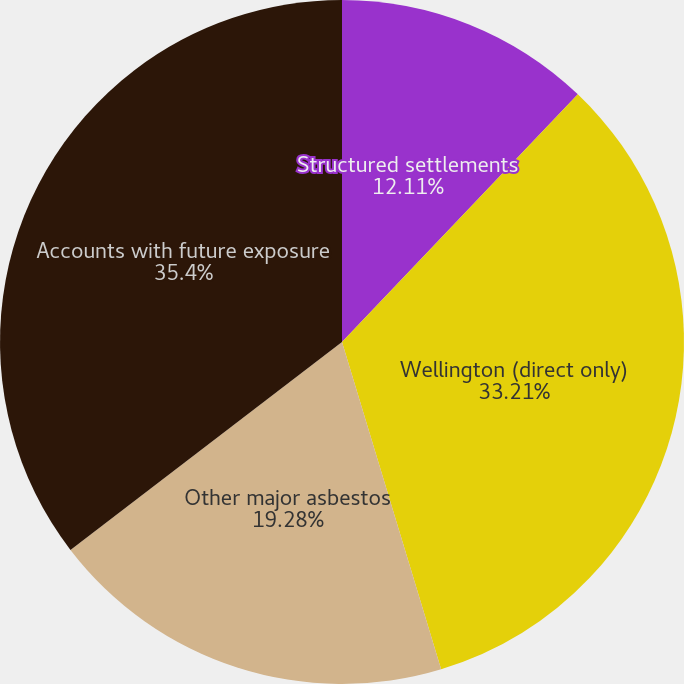Convert chart to OTSL. <chart><loc_0><loc_0><loc_500><loc_500><pie_chart><fcel>Structured settlements<fcel>Wellington (direct only)<fcel>Other major asbestos<fcel>Accounts with future exposure<nl><fcel>12.11%<fcel>33.21%<fcel>19.28%<fcel>35.4%<nl></chart> 